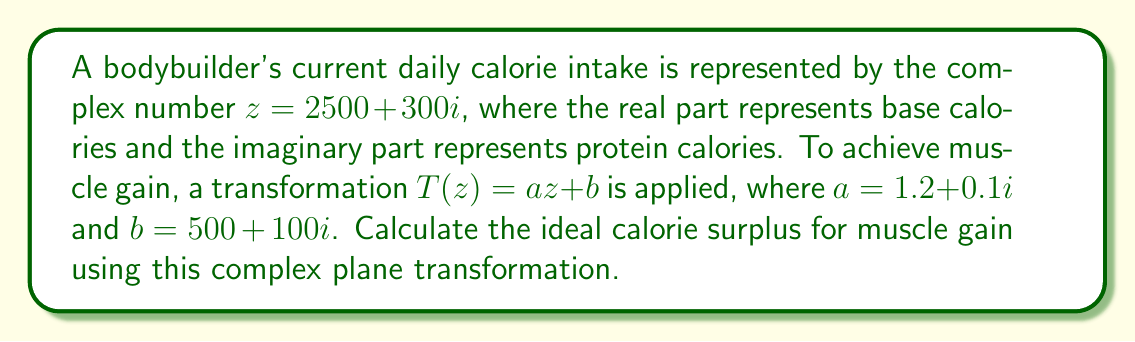Show me your answer to this math problem. 1) We start with the complex number $z = 2500 + 300i$ representing current calorie intake.

2) The transformation is given by $T(z) = az + b$, where:
   $a = 1.2 + 0.1i$
   $b = 500 + 100i$

3) Let's calculate $az$:
   $az = (1.2 + 0.1i)(2500 + 300i)$
   $= 3000 + 360i + 250i + 30i^2$
   $= 3000 + 610i - 30$ (since $i^2 = -1$)
   $= 2970 + 610i$

4) Now, we add $b$ to $az$:
   $T(z) = az + b = (2970 + 610i) + (500 + 100i)$
   $= 3470 + 710i$

5) The transformed calorie intake is $3470 + 710i$.

6) To find the calorie surplus, we subtract the original intake from the transformed intake:
   $(3470 + 710i) - (2500 + 300i) = 970 + 410i$

7) The real part (970) represents the base calorie surplus, and the imaginary part (410) represents the protein calorie surplus.

8) The total calorie surplus is the magnitude of this complex number:
   $\sqrt{970^2 + 410^2} \approx 1054.75$
Answer: 1055 calories 